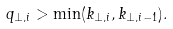<formula> <loc_0><loc_0><loc_500><loc_500>q _ { \perp , i } > \min ( k _ { \perp , i } , k _ { \perp , i - 1 } ) .</formula> 